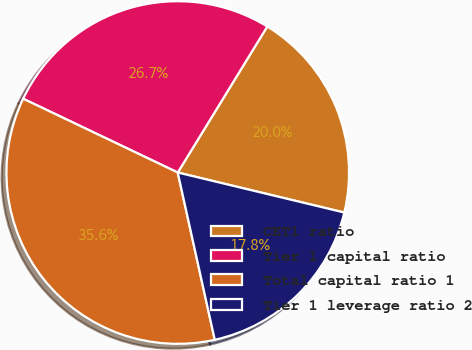<chart> <loc_0><loc_0><loc_500><loc_500><pie_chart><fcel>CET1 ratio<fcel>Tier 1 capital ratio<fcel>Total capital ratio 1<fcel>Tier 1 leverage ratio 2<nl><fcel>20.0%<fcel>26.67%<fcel>35.56%<fcel>17.78%<nl></chart> 